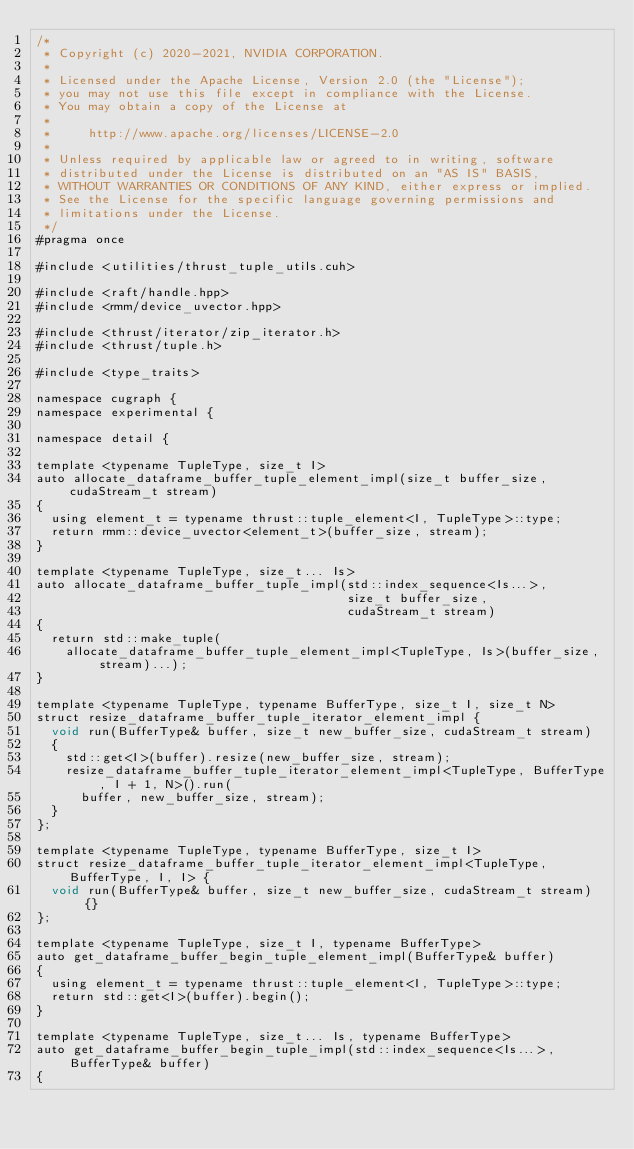Convert code to text. <code><loc_0><loc_0><loc_500><loc_500><_Cuda_>/*
 * Copyright (c) 2020-2021, NVIDIA CORPORATION.
 *
 * Licensed under the Apache License, Version 2.0 (the "License");
 * you may not use this file except in compliance with the License.
 * You may obtain a copy of the License at
 *
 *     http://www.apache.org/licenses/LICENSE-2.0
 *
 * Unless required by applicable law or agreed to in writing, software
 * distributed under the License is distributed on an "AS IS" BASIS,
 * WITHOUT WARRANTIES OR CONDITIONS OF ANY KIND, either express or implied.
 * See the License for the specific language governing permissions and
 * limitations under the License.
 */
#pragma once

#include <utilities/thrust_tuple_utils.cuh>

#include <raft/handle.hpp>
#include <rmm/device_uvector.hpp>

#include <thrust/iterator/zip_iterator.h>
#include <thrust/tuple.h>

#include <type_traits>

namespace cugraph {
namespace experimental {

namespace detail {

template <typename TupleType, size_t I>
auto allocate_dataframe_buffer_tuple_element_impl(size_t buffer_size, cudaStream_t stream)
{
  using element_t = typename thrust::tuple_element<I, TupleType>::type;
  return rmm::device_uvector<element_t>(buffer_size, stream);
}

template <typename TupleType, size_t... Is>
auto allocate_dataframe_buffer_tuple_impl(std::index_sequence<Is...>,
                                          size_t buffer_size,
                                          cudaStream_t stream)
{
  return std::make_tuple(
    allocate_dataframe_buffer_tuple_element_impl<TupleType, Is>(buffer_size, stream)...);
}

template <typename TupleType, typename BufferType, size_t I, size_t N>
struct resize_dataframe_buffer_tuple_iterator_element_impl {
  void run(BufferType& buffer, size_t new_buffer_size, cudaStream_t stream)
  {
    std::get<I>(buffer).resize(new_buffer_size, stream);
    resize_dataframe_buffer_tuple_iterator_element_impl<TupleType, BufferType, I + 1, N>().run(
      buffer, new_buffer_size, stream);
  }
};

template <typename TupleType, typename BufferType, size_t I>
struct resize_dataframe_buffer_tuple_iterator_element_impl<TupleType, BufferType, I, I> {
  void run(BufferType& buffer, size_t new_buffer_size, cudaStream_t stream) {}
};

template <typename TupleType, size_t I, typename BufferType>
auto get_dataframe_buffer_begin_tuple_element_impl(BufferType& buffer)
{
  using element_t = typename thrust::tuple_element<I, TupleType>::type;
  return std::get<I>(buffer).begin();
}

template <typename TupleType, size_t... Is, typename BufferType>
auto get_dataframe_buffer_begin_tuple_impl(std::index_sequence<Is...>, BufferType& buffer)
{</code> 